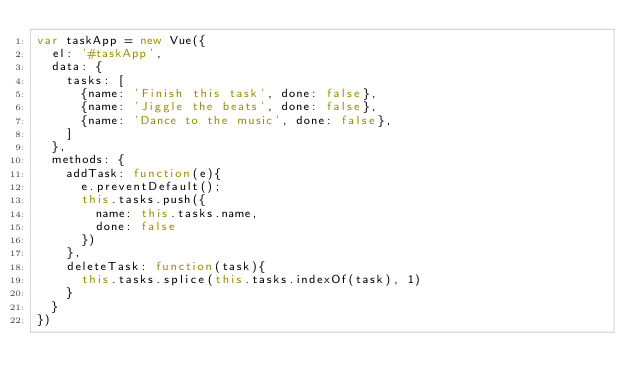<code> <loc_0><loc_0><loc_500><loc_500><_JavaScript_>var taskApp = new Vue({
  el: '#taskApp',
  data: {
    tasks: [
      {name: 'Finish this task', done: false},
      {name: 'Jiggle the beats', done: false},
      {name: 'Dance to the music', done: false},
    ]
  },
  methods: {
    addTask: function(e){
      e.preventDefault();
      this.tasks.push({
        name: this.tasks.name,
        done: false
      })
    },
    deleteTask: function(task){
      this.tasks.splice(this.tasks.indexOf(task), 1)
    }
  }
})
</code> 